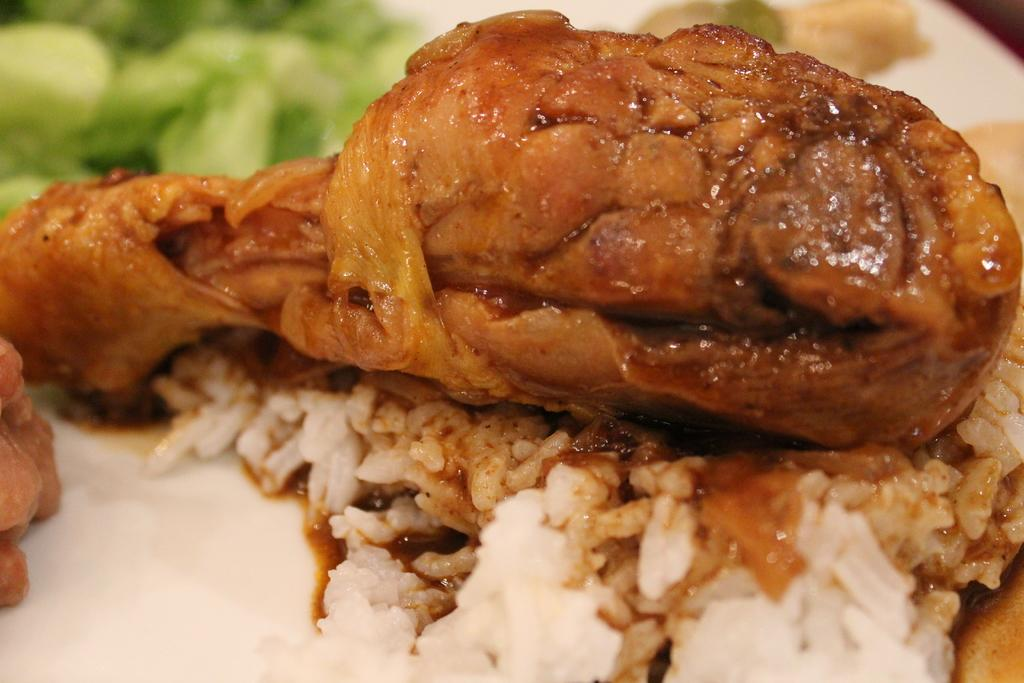What type of food can be seen in the image? There is food in the image, specifically rice on a plate. Can you describe the dish containing the food? The dish is a plate, and it contains rice. How many tramps are visible in the image? There are no tramps present in the image. What type of car is parked next to the plate of rice in the image? There is no car present in the image. 